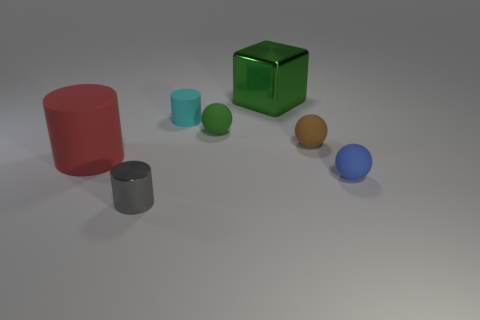What number of things are either tiny rubber objects that are left of the green block or objects on the left side of the gray thing?
Offer a terse response. 3. There is a large object behind the matte ball that is on the left side of the brown sphere; what is its material?
Provide a short and direct response. Metal. What number of other objects are the same material as the brown sphere?
Your response must be concise. 4. Is the red matte object the same shape as the cyan thing?
Offer a very short reply. Yes. There is a matte object right of the brown ball; what size is it?
Provide a short and direct response. Small. There is a brown rubber thing; is it the same size as the rubber sphere behind the tiny brown matte sphere?
Provide a succinct answer. Yes. Is the number of small brown rubber objects that are behind the cube less than the number of brown matte balls?
Keep it short and to the point. Yes. There is a brown thing that is the same shape as the blue thing; what material is it?
Provide a short and direct response. Rubber. There is a small rubber object that is to the left of the brown sphere and in front of the cyan matte thing; what shape is it?
Your response must be concise. Sphere. The small blue object that is made of the same material as the tiny green sphere is what shape?
Your answer should be compact. Sphere. 